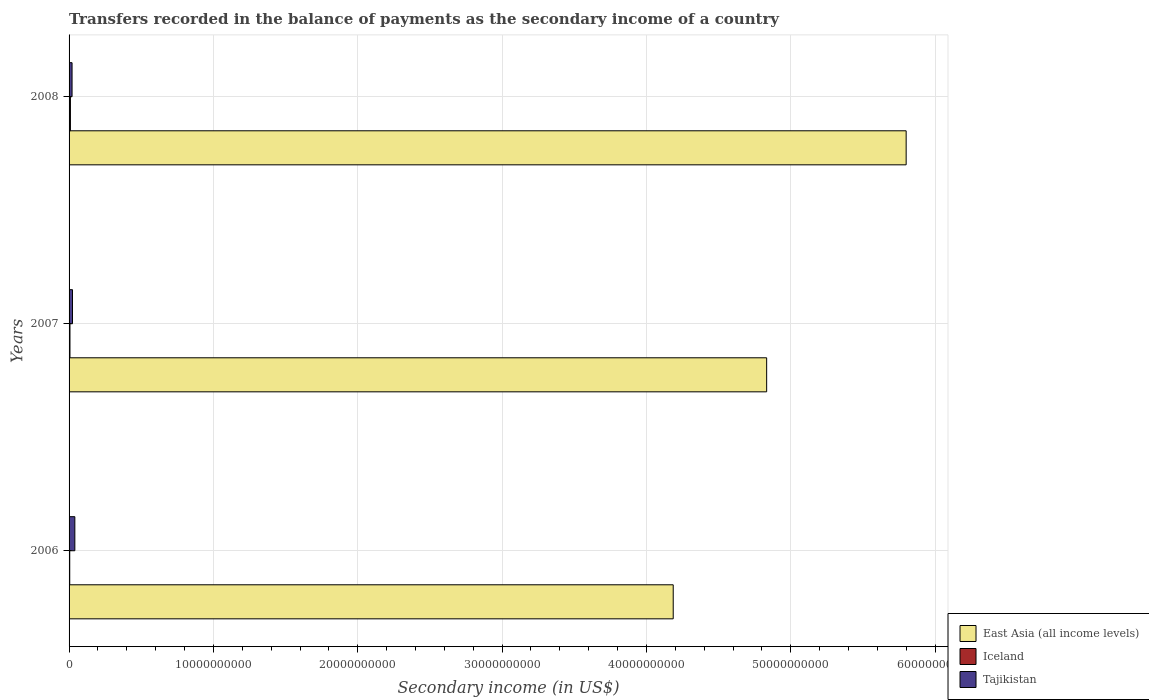How many different coloured bars are there?
Your response must be concise. 3. How many groups of bars are there?
Provide a succinct answer. 3. Are the number of bars per tick equal to the number of legend labels?
Provide a short and direct response. Yes. Are the number of bars on each tick of the Y-axis equal?
Your answer should be very brief. Yes. How many bars are there on the 3rd tick from the top?
Your answer should be very brief. 3. What is the label of the 3rd group of bars from the top?
Your response must be concise. 2006. What is the secondary income of in East Asia (all income levels) in 2008?
Offer a very short reply. 5.80e+1. Across all years, what is the maximum secondary income of in Iceland?
Your answer should be very brief. 9.39e+07. Across all years, what is the minimum secondary income of in Iceland?
Provide a succinct answer. 4.65e+07. What is the total secondary income of in East Asia (all income levels) in the graph?
Provide a short and direct response. 1.48e+11. What is the difference between the secondary income of in Iceland in 2006 and that in 2007?
Make the answer very short. -1.53e+07. What is the difference between the secondary income of in East Asia (all income levels) in 2006 and the secondary income of in Iceland in 2007?
Make the answer very short. 4.18e+1. What is the average secondary income of in Tajikistan per year?
Provide a short and direct response. 2.81e+08. In the year 2007, what is the difference between the secondary income of in Iceland and secondary income of in Tajikistan?
Your answer should be very brief. -1.75e+08. What is the ratio of the secondary income of in Tajikistan in 2007 to that in 2008?
Offer a very short reply. 1.15. Is the secondary income of in Tajikistan in 2007 less than that in 2008?
Your response must be concise. No. What is the difference between the highest and the second highest secondary income of in Iceland?
Make the answer very short. 3.22e+07. What is the difference between the highest and the lowest secondary income of in East Asia (all income levels)?
Give a very brief answer. 1.61e+1. In how many years, is the secondary income of in Tajikistan greater than the average secondary income of in Tajikistan taken over all years?
Your answer should be very brief. 1. Is the sum of the secondary income of in East Asia (all income levels) in 2006 and 2008 greater than the maximum secondary income of in Tajikistan across all years?
Your answer should be compact. Yes. What does the 3rd bar from the top in 2006 represents?
Your answer should be compact. East Asia (all income levels). What does the 3rd bar from the bottom in 2006 represents?
Provide a short and direct response. Tajikistan. Is it the case that in every year, the sum of the secondary income of in Iceland and secondary income of in Tajikistan is greater than the secondary income of in East Asia (all income levels)?
Provide a succinct answer. No. How many years are there in the graph?
Make the answer very short. 3. Does the graph contain any zero values?
Your answer should be very brief. No. Where does the legend appear in the graph?
Offer a very short reply. Bottom right. How many legend labels are there?
Give a very brief answer. 3. How are the legend labels stacked?
Your answer should be compact. Vertical. What is the title of the graph?
Make the answer very short. Transfers recorded in the balance of payments as the secondary income of a country. What is the label or title of the X-axis?
Provide a succinct answer. Secondary income (in US$). What is the label or title of the Y-axis?
Your answer should be very brief. Years. What is the Secondary income (in US$) of East Asia (all income levels) in 2006?
Your response must be concise. 4.19e+1. What is the Secondary income (in US$) in Iceland in 2006?
Your answer should be compact. 4.65e+07. What is the Secondary income (in US$) of Tajikistan in 2006?
Keep it short and to the point. 4.00e+08. What is the Secondary income (in US$) in East Asia (all income levels) in 2007?
Give a very brief answer. 4.83e+1. What is the Secondary income (in US$) in Iceland in 2007?
Offer a very short reply. 6.18e+07. What is the Secondary income (in US$) in Tajikistan in 2007?
Your response must be concise. 2.37e+08. What is the Secondary income (in US$) of East Asia (all income levels) in 2008?
Keep it short and to the point. 5.80e+1. What is the Secondary income (in US$) of Iceland in 2008?
Provide a short and direct response. 9.39e+07. What is the Secondary income (in US$) of Tajikistan in 2008?
Make the answer very short. 2.07e+08. Across all years, what is the maximum Secondary income (in US$) of East Asia (all income levels)?
Your answer should be compact. 5.80e+1. Across all years, what is the maximum Secondary income (in US$) in Iceland?
Keep it short and to the point. 9.39e+07. Across all years, what is the maximum Secondary income (in US$) in Tajikistan?
Your response must be concise. 4.00e+08. Across all years, what is the minimum Secondary income (in US$) of East Asia (all income levels)?
Provide a short and direct response. 4.19e+1. Across all years, what is the minimum Secondary income (in US$) of Iceland?
Your response must be concise. 4.65e+07. Across all years, what is the minimum Secondary income (in US$) in Tajikistan?
Provide a succinct answer. 2.07e+08. What is the total Secondary income (in US$) of East Asia (all income levels) in the graph?
Your answer should be compact. 1.48e+11. What is the total Secondary income (in US$) of Iceland in the graph?
Your answer should be compact. 2.02e+08. What is the total Secondary income (in US$) in Tajikistan in the graph?
Ensure brevity in your answer.  8.44e+08. What is the difference between the Secondary income (in US$) of East Asia (all income levels) in 2006 and that in 2007?
Offer a very short reply. -6.47e+09. What is the difference between the Secondary income (in US$) of Iceland in 2006 and that in 2007?
Make the answer very short. -1.53e+07. What is the difference between the Secondary income (in US$) of Tajikistan in 2006 and that in 2007?
Ensure brevity in your answer.  1.63e+08. What is the difference between the Secondary income (in US$) in East Asia (all income levels) in 2006 and that in 2008?
Give a very brief answer. -1.61e+1. What is the difference between the Secondary income (in US$) of Iceland in 2006 and that in 2008?
Give a very brief answer. -4.75e+07. What is the difference between the Secondary income (in US$) of Tajikistan in 2006 and that in 2008?
Offer a terse response. 1.94e+08. What is the difference between the Secondary income (in US$) of East Asia (all income levels) in 2007 and that in 2008?
Your answer should be compact. -9.67e+09. What is the difference between the Secondary income (in US$) of Iceland in 2007 and that in 2008?
Keep it short and to the point. -3.22e+07. What is the difference between the Secondary income (in US$) in Tajikistan in 2007 and that in 2008?
Your answer should be compact. 3.03e+07. What is the difference between the Secondary income (in US$) in East Asia (all income levels) in 2006 and the Secondary income (in US$) in Iceland in 2007?
Provide a short and direct response. 4.18e+1. What is the difference between the Secondary income (in US$) of East Asia (all income levels) in 2006 and the Secondary income (in US$) of Tajikistan in 2007?
Offer a very short reply. 4.16e+1. What is the difference between the Secondary income (in US$) in Iceland in 2006 and the Secondary income (in US$) in Tajikistan in 2007?
Give a very brief answer. -1.91e+08. What is the difference between the Secondary income (in US$) of East Asia (all income levels) in 2006 and the Secondary income (in US$) of Iceland in 2008?
Offer a very short reply. 4.18e+1. What is the difference between the Secondary income (in US$) in East Asia (all income levels) in 2006 and the Secondary income (in US$) in Tajikistan in 2008?
Make the answer very short. 4.17e+1. What is the difference between the Secondary income (in US$) of Iceland in 2006 and the Secondary income (in US$) of Tajikistan in 2008?
Give a very brief answer. -1.60e+08. What is the difference between the Secondary income (in US$) of East Asia (all income levels) in 2007 and the Secondary income (in US$) of Iceland in 2008?
Make the answer very short. 4.82e+1. What is the difference between the Secondary income (in US$) of East Asia (all income levels) in 2007 and the Secondary income (in US$) of Tajikistan in 2008?
Your response must be concise. 4.81e+1. What is the difference between the Secondary income (in US$) of Iceland in 2007 and the Secondary income (in US$) of Tajikistan in 2008?
Your answer should be very brief. -1.45e+08. What is the average Secondary income (in US$) of East Asia (all income levels) per year?
Your answer should be very brief. 4.94e+1. What is the average Secondary income (in US$) in Iceland per year?
Offer a terse response. 6.74e+07. What is the average Secondary income (in US$) of Tajikistan per year?
Provide a short and direct response. 2.81e+08. In the year 2006, what is the difference between the Secondary income (in US$) in East Asia (all income levels) and Secondary income (in US$) in Iceland?
Give a very brief answer. 4.18e+1. In the year 2006, what is the difference between the Secondary income (in US$) of East Asia (all income levels) and Secondary income (in US$) of Tajikistan?
Keep it short and to the point. 4.15e+1. In the year 2006, what is the difference between the Secondary income (in US$) in Iceland and Secondary income (in US$) in Tajikistan?
Provide a short and direct response. -3.54e+08. In the year 2007, what is the difference between the Secondary income (in US$) in East Asia (all income levels) and Secondary income (in US$) in Iceland?
Your response must be concise. 4.83e+1. In the year 2007, what is the difference between the Secondary income (in US$) in East Asia (all income levels) and Secondary income (in US$) in Tajikistan?
Your response must be concise. 4.81e+1. In the year 2007, what is the difference between the Secondary income (in US$) of Iceland and Secondary income (in US$) of Tajikistan?
Offer a very short reply. -1.75e+08. In the year 2008, what is the difference between the Secondary income (in US$) of East Asia (all income levels) and Secondary income (in US$) of Iceland?
Your answer should be compact. 5.79e+1. In the year 2008, what is the difference between the Secondary income (in US$) of East Asia (all income levels) and Secondary income (in US$) of Tajikistan?
Give a very brief answer. 5.78e+1. In the year 2008, what is the difference between the Secondary income (in US$) in Iceland and Secondary income (in US$) in Tajikistan?
Your response must be concise. -1.13e+08. What is the ratio of the Secondary income (in US$) of East Asia (all income levels) in 2006 to that in 2007?
Your answer should be very brief. 0.87. What is the ratio of the Secondary income (in US$) in Iceland in 2006 to that in 2007?
Give a very brief answer. 0.75. What is the ratio of the Secondary income (in US$) of Tajikistan in 2006 to that in 2007?
Your answer should be very brief. 1.69. What is the ratio of the Secondary income (in US$) of East Asia (all income levels) in 2006 to that in 2008?
Keep it short and to the point. 0.72. What is the ratio of the Secondary income (in US$) of Iceland in 2006 to that in 2008?
Give a very brief answer. 0.49. What is the ratio of the Secondary income (in US$) in Tajikistan in 2006 to that in 2008?
Your answer should be very brief. 1.94. What is the ratio of the Secondary income (in US$) in East Asia (all income levels) in 2007 to that in 2008?
Offer a terse response. 0.83. What is the ratio of the Secondary income (in US$) of Iceland in 2007 to that in 2008?
Make the answer very short. 0.66. What is the ratio of the Secondary income (in US$) of Tajikistan in 2007 to that in 2008?
Provide a short and direct response. 1.15. What is the difference between the highest and the second highest Secondary income (in US$) in East Asia (all income levels)?
Ensure brevity in your answer.  9.67e+09. What is the difference between the highest and the second highest Secondary income (in US$) of Iceland?
Provide a succinct answer. 3.22e+07. What is the difference between the highest and the second highest Secondary income (in US$) of Tajikistan?
Offer a very short reply. 1.63e+08. What is the difference between the highest and the lowest Secondary income (in US$) of East Asia (all income levels)?
Give a very brief answer. 1.61e+1. What is the difference between the highest and the lowest Secondary income (in US$) of Iceland?
Offer a very short reply. 4.75e+07. What is the difference between the highest and the lowest Secondary income (in US$) in Tajikistan?
Your answer should be very brief. 1.94e+08. 